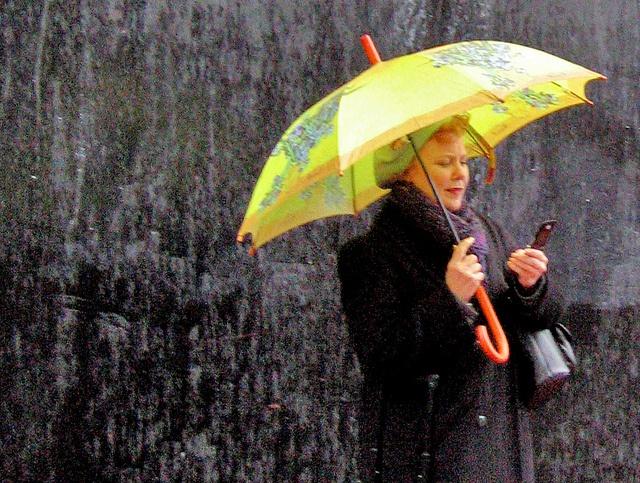Describe the objects in this image and their specific colors. I can see people in black, gray, maroon, and tan tones, umbrella in black, khaki, beige, and olive tones, handbag in black, darkgray, gray, and maroon tones, and cell phone in black, maroon, brown, and purple tones in this image. 